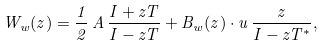<formula> <loc_0><loc_0><loc_500><loc_500>W _ { w } ( z ) = \frac { 1 } { 2 } \, A \, \frac { I + z T } { I - z T } + B _ { w } ( z ) \cdot u \, \frac { z } { I - z T ^ { \ast } } ,</formula> 